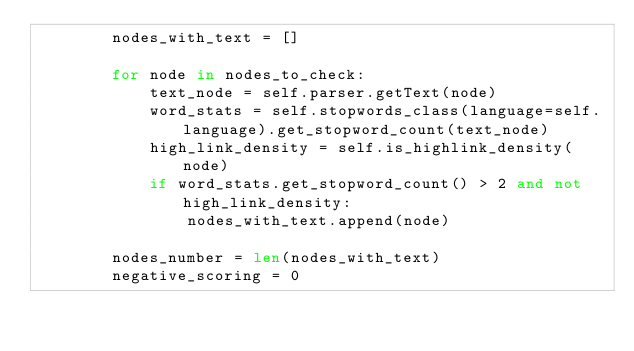Convert code to text. <code><loc_0><loc_0><loc_500><loc_500><_Python_>        nodes_with_text = []

        for node in nodes_to_check:
            text_node = self.parser.getText(node)
            word_stats = self.stopwords_class(language=self.language).get_stopword_count(text_node)
            high_link_density = self.is_highlink_density(node)
            if word_stats.get_stopword_count() > 2 and not high_link_density:
                nodes_with_text.append(node)

        nodes_number = len(nodes_with_text)
        negative_scoring = 0</code> 